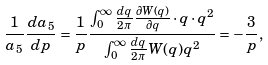Convert formula to latex. <formula><loc_0><loc_0><loc_500><loc_500>\frac { 1 } { a _ { 5 } } \frac { d a _ { 5 } } { d p } = \frac { 1 } { p } \frac { \int _ { 0 } ^ { \infty } \frac { d q } { 2 \pi } \frac { \partial W ( q ) } { \partial q } \cdot q \cdot q ^ { 2 } } { \int _ { 0 } ^ { \infty } \frac { d q } { 2 \pi } W ( q ) q ^ { 2 } } = - \frac { 3 } { p } ,</formula> 